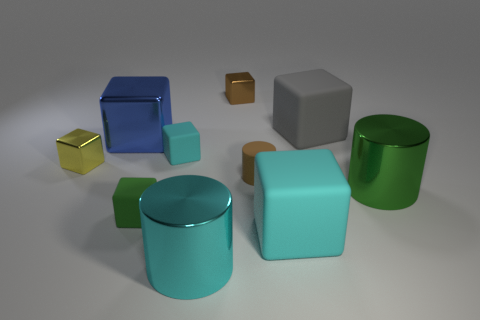Subtract all brown cubes. How many cubes are left? 6 Subtract all cyan cylinders. How many cylinders are left? 2 Subtract all purple cylinders. How many cyan cubes are left? 2 Subtract 1 cylinders. How many cylinders are left? 2 Subtract all cylinders. How many objects are left? 7 Subtract all red cylinders. Subtract all green balls. How many cylinders are left? 3 Subtract all large matte blocks. Subtract all blue blocks. How many objects are left? 7 Add 4 tiny shiny blocks. How many tiny shiny blocks are left? 6 Add 3 green shiny cylinders. How many green shiny cylinders exist? 4 Subtract 0 purple spheres. How many objects are left? 10 